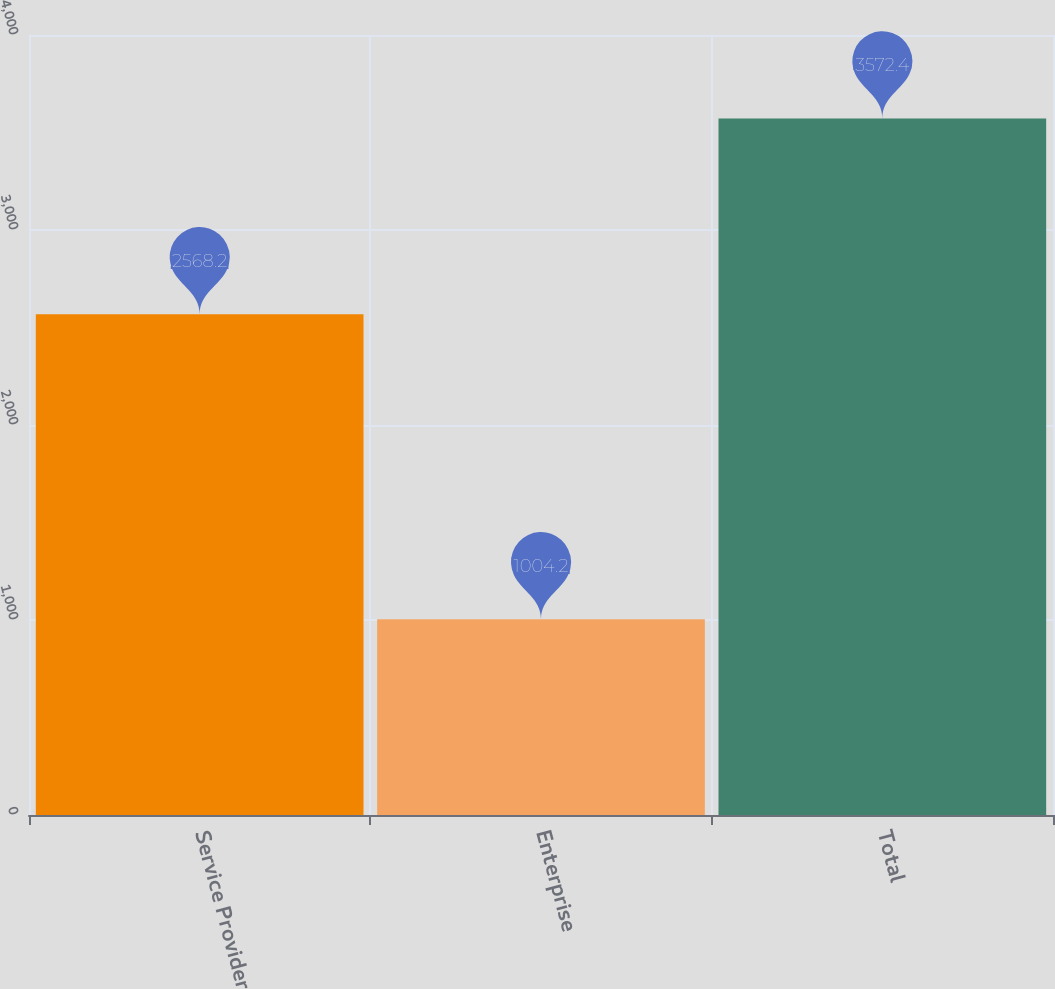<chart> <loc_0><loc_0><loc_500><loc_500><bar_chart><fcel>Service Provider<fcel>Enterprise<fcel>Total<nl><fcel>2568.2<fcel>1004.2<fcel>3572.4<nl></chart> 